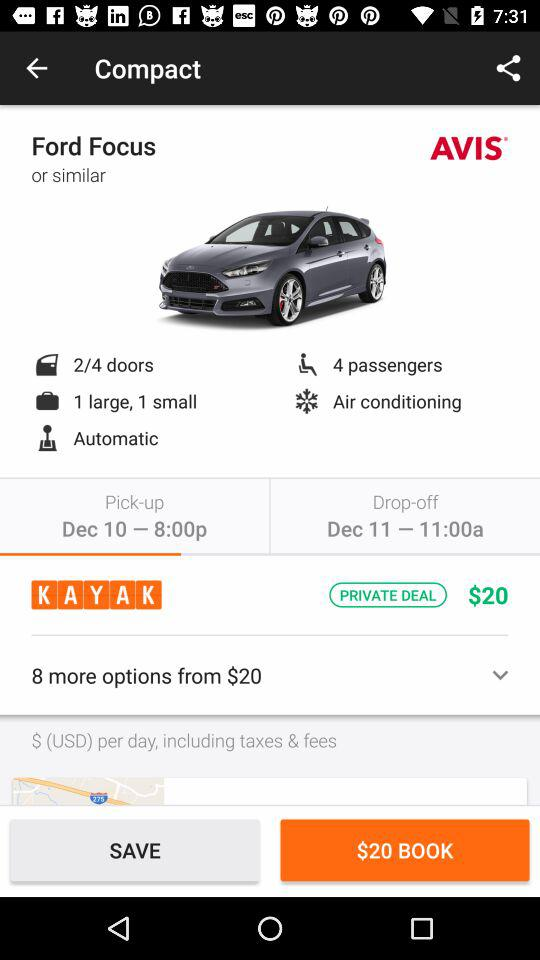How many passengers does the car seat?
Answer the question using a single word or phrase. 4 